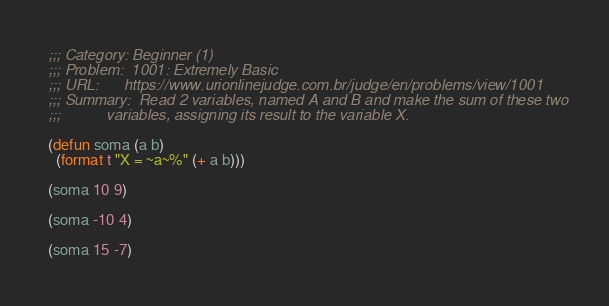<code> <loc_0><loc_0><loc_500><loc_500><_Lisp_>
;;; Category: Beginner (1)
;;; Problem:  1001: Extremely Basic
;;; URL:      https://www.urionlinejudge.com.br/judge/en/problems/view/1001
;;; Summary:  Read 2 variables, named A and B and make the sum of these two
;;;           variables, assigning its result to the variable X.

(defun soma (a b)
  (format t "X = ~a~%" (+ a b)))

(soma 10 9)

(soma -10 4)

(soma 15 -7)
</code> 